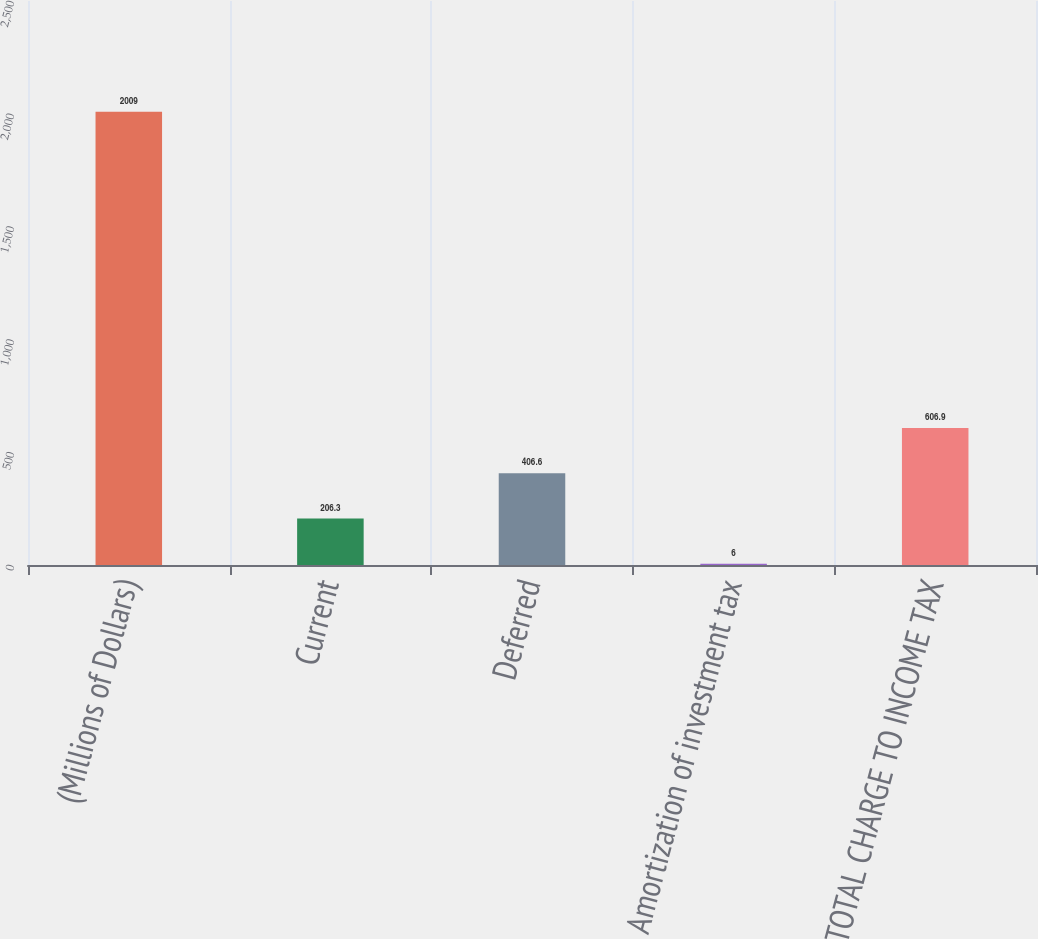Convert chart. <chart><loc_0><loc_0><loc_500><loc_500><bar_chart><fcel>(Millions of Dollars)<fcel>Current<fcel>Deferred<fcel>Amortization of investment tax<fcel>TOTAL CHARGE TO INCOME TAX<nl><fcel>2009<fcel>206.3<fcel>406.6<fcel>6<fcel>606.9<nl></chart> 